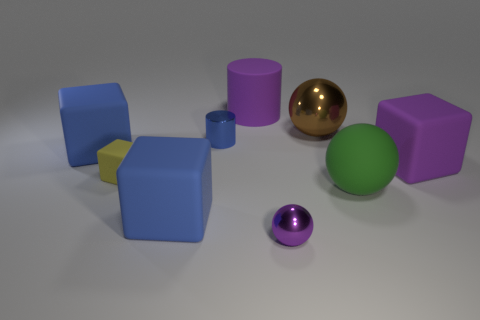Do the tiny cylinder and the rubber cube that is behind the large purple cube have the same color?
Give a very brief answer. Yes. Are there fewer tiny things to the right of the green matte sphere than tiny things?
Provide a short and direct response. Yes. There is a large purple object on the left side of the tiny shiny sphere; what is its material?
Ensure brevity in your answer.  Rubber. How many other things are there of the same size as the purple rubber cylinder?
Ensure brevity in your answer.  5. Is the size of the blue cylinder the same as the metal sphere that is behind the purple sphere?
Provide a short and direct response. No. There is a blue matte object that is in front of the big matte block right of the large purple matte object that is left of the rubber sphere; what shape is it?
Your answer should be compact. Cube. Is the number of small purple metal things less than the number of green shiny spheres?
Provide a short and direct response. No. There is a small purple metallic object; are there any big blue things to the left of it?
Provide a short and direct response. Yes. The rubber thing that is both to the right of the brown metallic thing and in front of the purple cube has what shape?
Keep it short and to the point. Sphere. Is there a purple object of the same shape as the blue metal object?
Offer a terse response. Yes. 